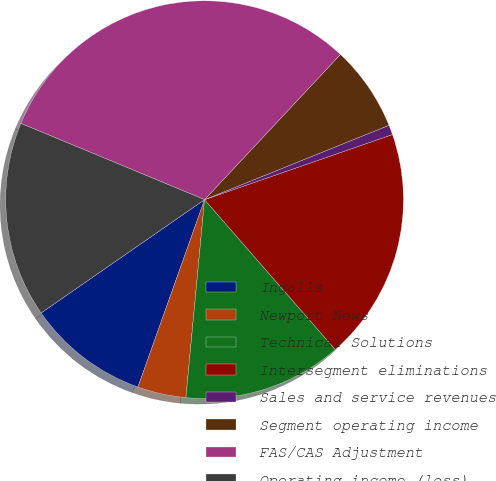Convert chart. <chart><loc_0><loc_0><loc_500><loc_500><pie_chart><fcel>Ingalls<fcel>Newport News<fcel>Technical Solutions<fcel>Intersegment eliminations<fcel>Sales and service revenues<fcel>Segment operating income<fcel>FAS/CAS Adjustment<fcel>Operating income (loss)<nl><fcel>9.92%<fcel>3.94%<fcel>12.91%<fcel>18.9%<fcel>0.79%<fcel>6.93%<fcel>30.71%<fcel>15.91%<nl></chart> 